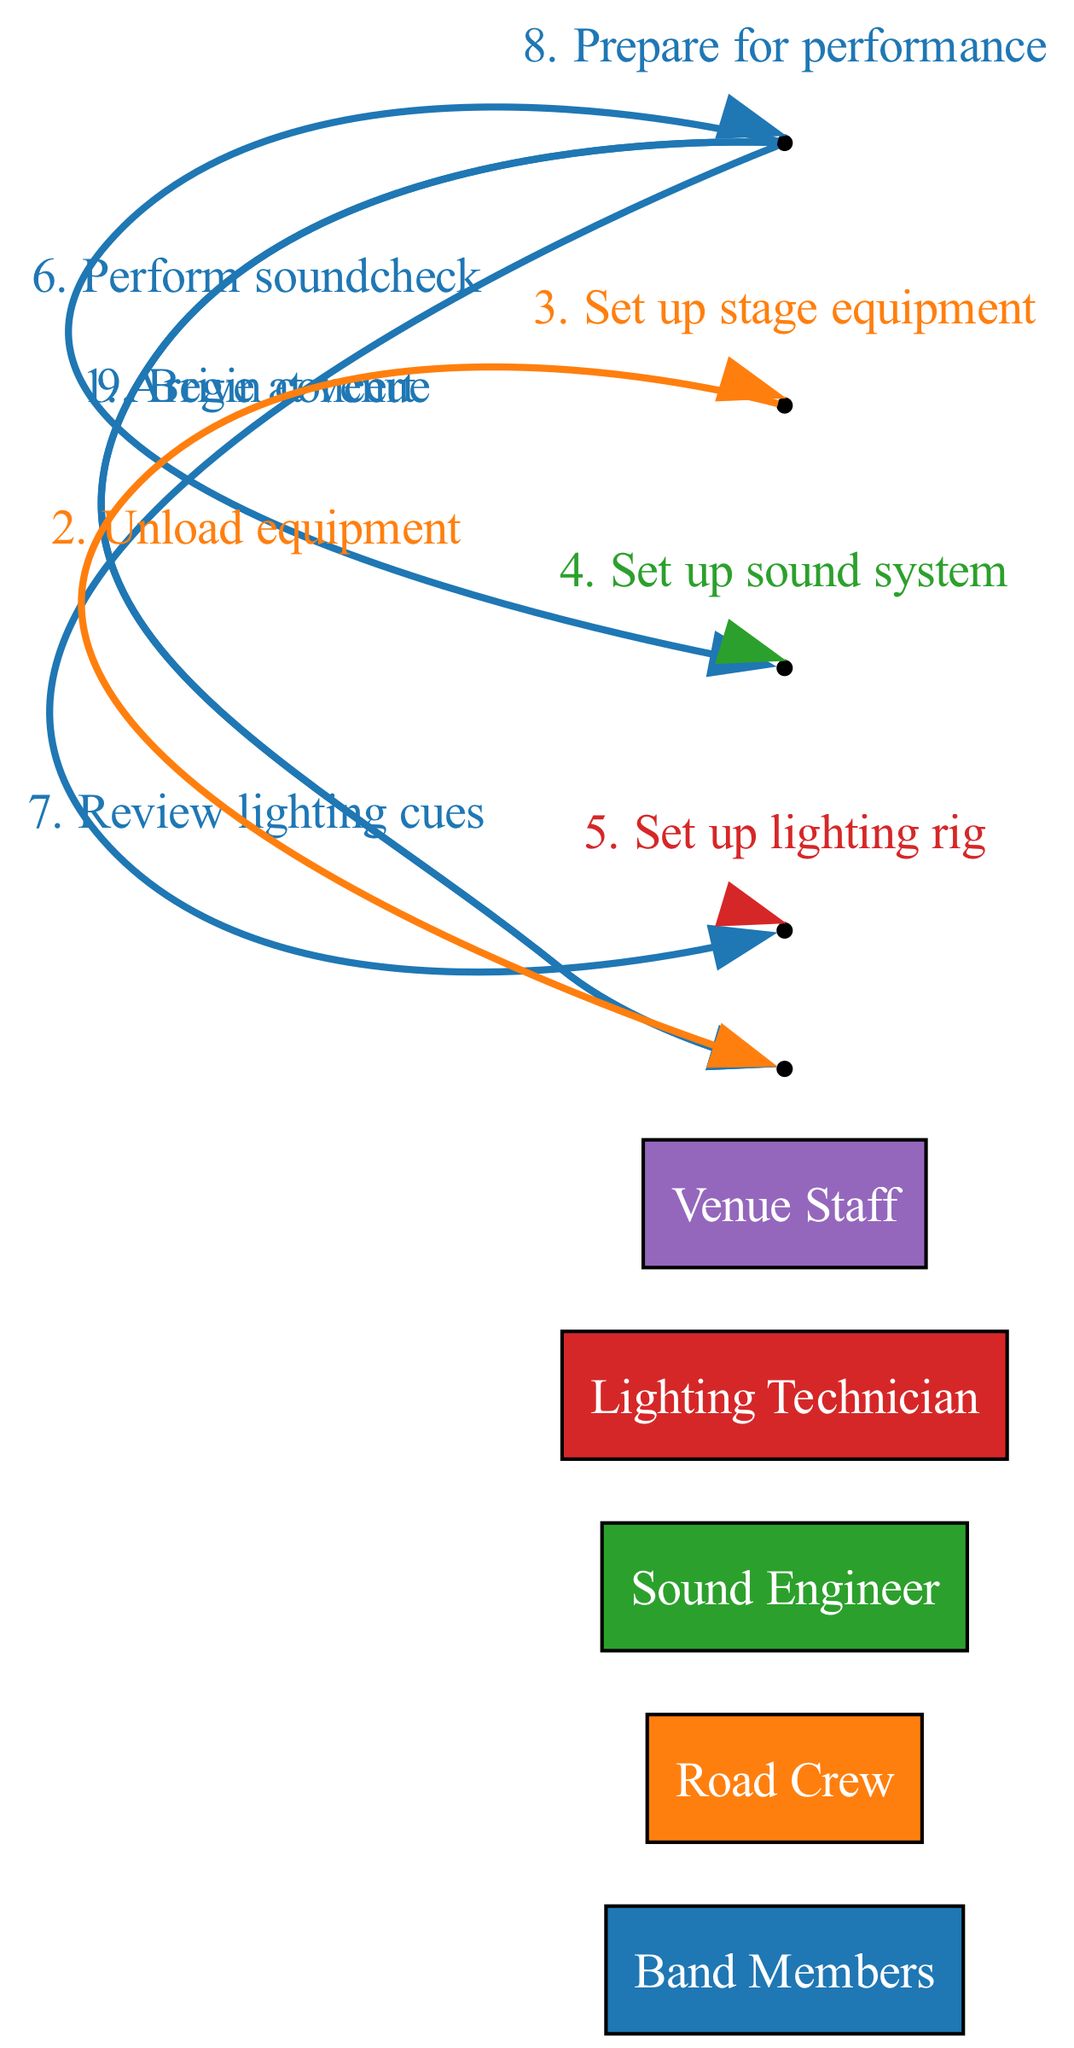What is the first action in the sequence? The first action in the sequence is "Arrive at venue," performed by the Band Members who interact with the Venue Staff.
Answer: Arrive at venue How many actors are involved in the concert setup process? The diagram lists five actors: Band Members, Road Crew, Sound Engineer, Lighting Technician, and Venue Staff.
Answer: 5 Which action is performed by the Lighting Technician? The Lighting Technician performs the action "Set up lighting rig," as indicated in the sequence of interactions.
Answer: Set up lighting rig Who does the Road Crew interact with most frequently? The Road Crew interacts primarily with itself while unloading and setting up equipment, seen in actions like "Unload equipment" and "Set up stage equipment."
Answer: Road Crew What is the last action causing the concert to begin? The last action that initiates the concert is "Begin concert," performed by the Band Members directing this toward the Venue Staff.
Answer: Begin concert How many self-loop actions are present in this sequence? There are three self-loop actions performed by the Road Crew, Sound Engineer, and Band Members indicated in the sequence.
Answer: 3 What action follows "Perform soundcheck"? The action that follows "Perform soundcheck" is "Review lighting cues," where Band Members interact with the Lighting Technician.
Answer: Review lighting cues Who sets up the sound system? The Sound Engineer is responsible for setting up the sound system, which is detailed in one of the sequence steps.
Answer: Sound Engineer Which two actors interact in the action "Prepare for performance"? The action "Prepare for performance" is a self-loop performed by the Band Members.
Answer: Band Members 